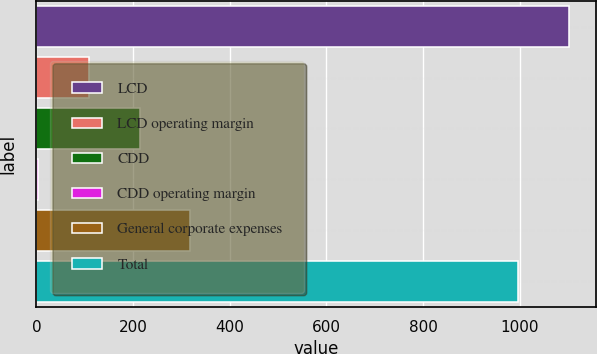<chart> <loc_0><loc_0><loc_500><loc_500><bar_chart><fcel>LCD<fcel>LCD operating margin<fcel>CDD<fcel>CDD operating margin<fcel>General corporate expenses<fcel>Total<nl><fcel>1101.85<fcel>108.25<fcel>213.3<fcel>3.2<fcel>318.35<fcel>996.8<nl></chart> 